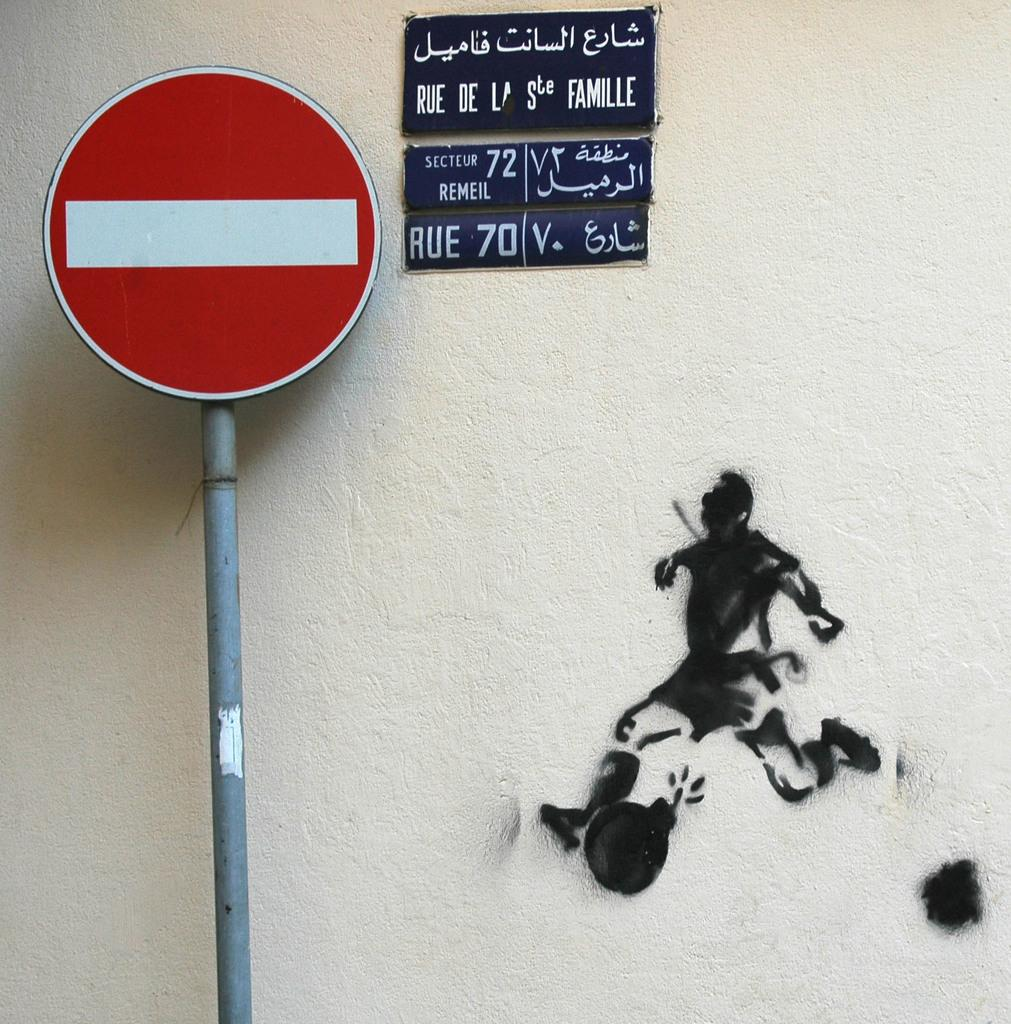<image>
Summarize the visual content of the image. A no entry sign next to a blue sign that says Rue De La Ste. Famille. 